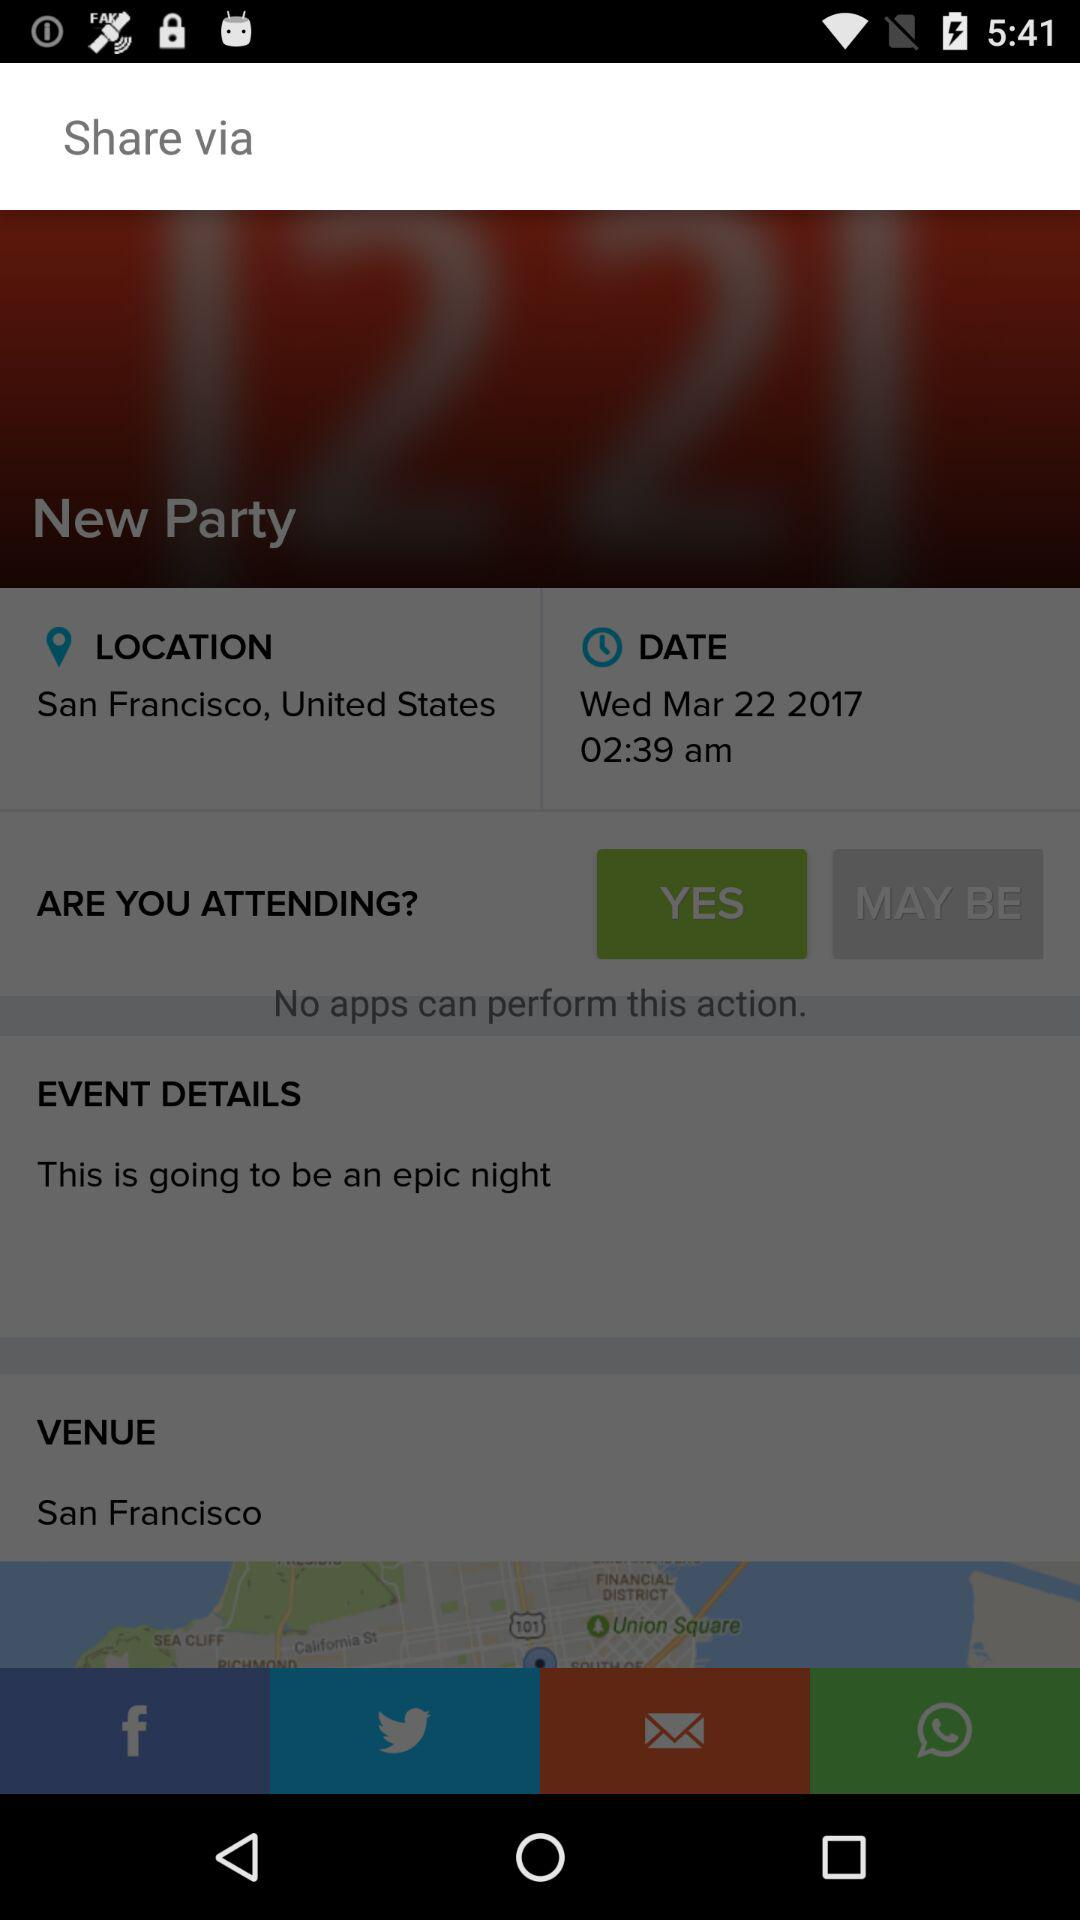What is the location? The location is San Francisco, United States. 